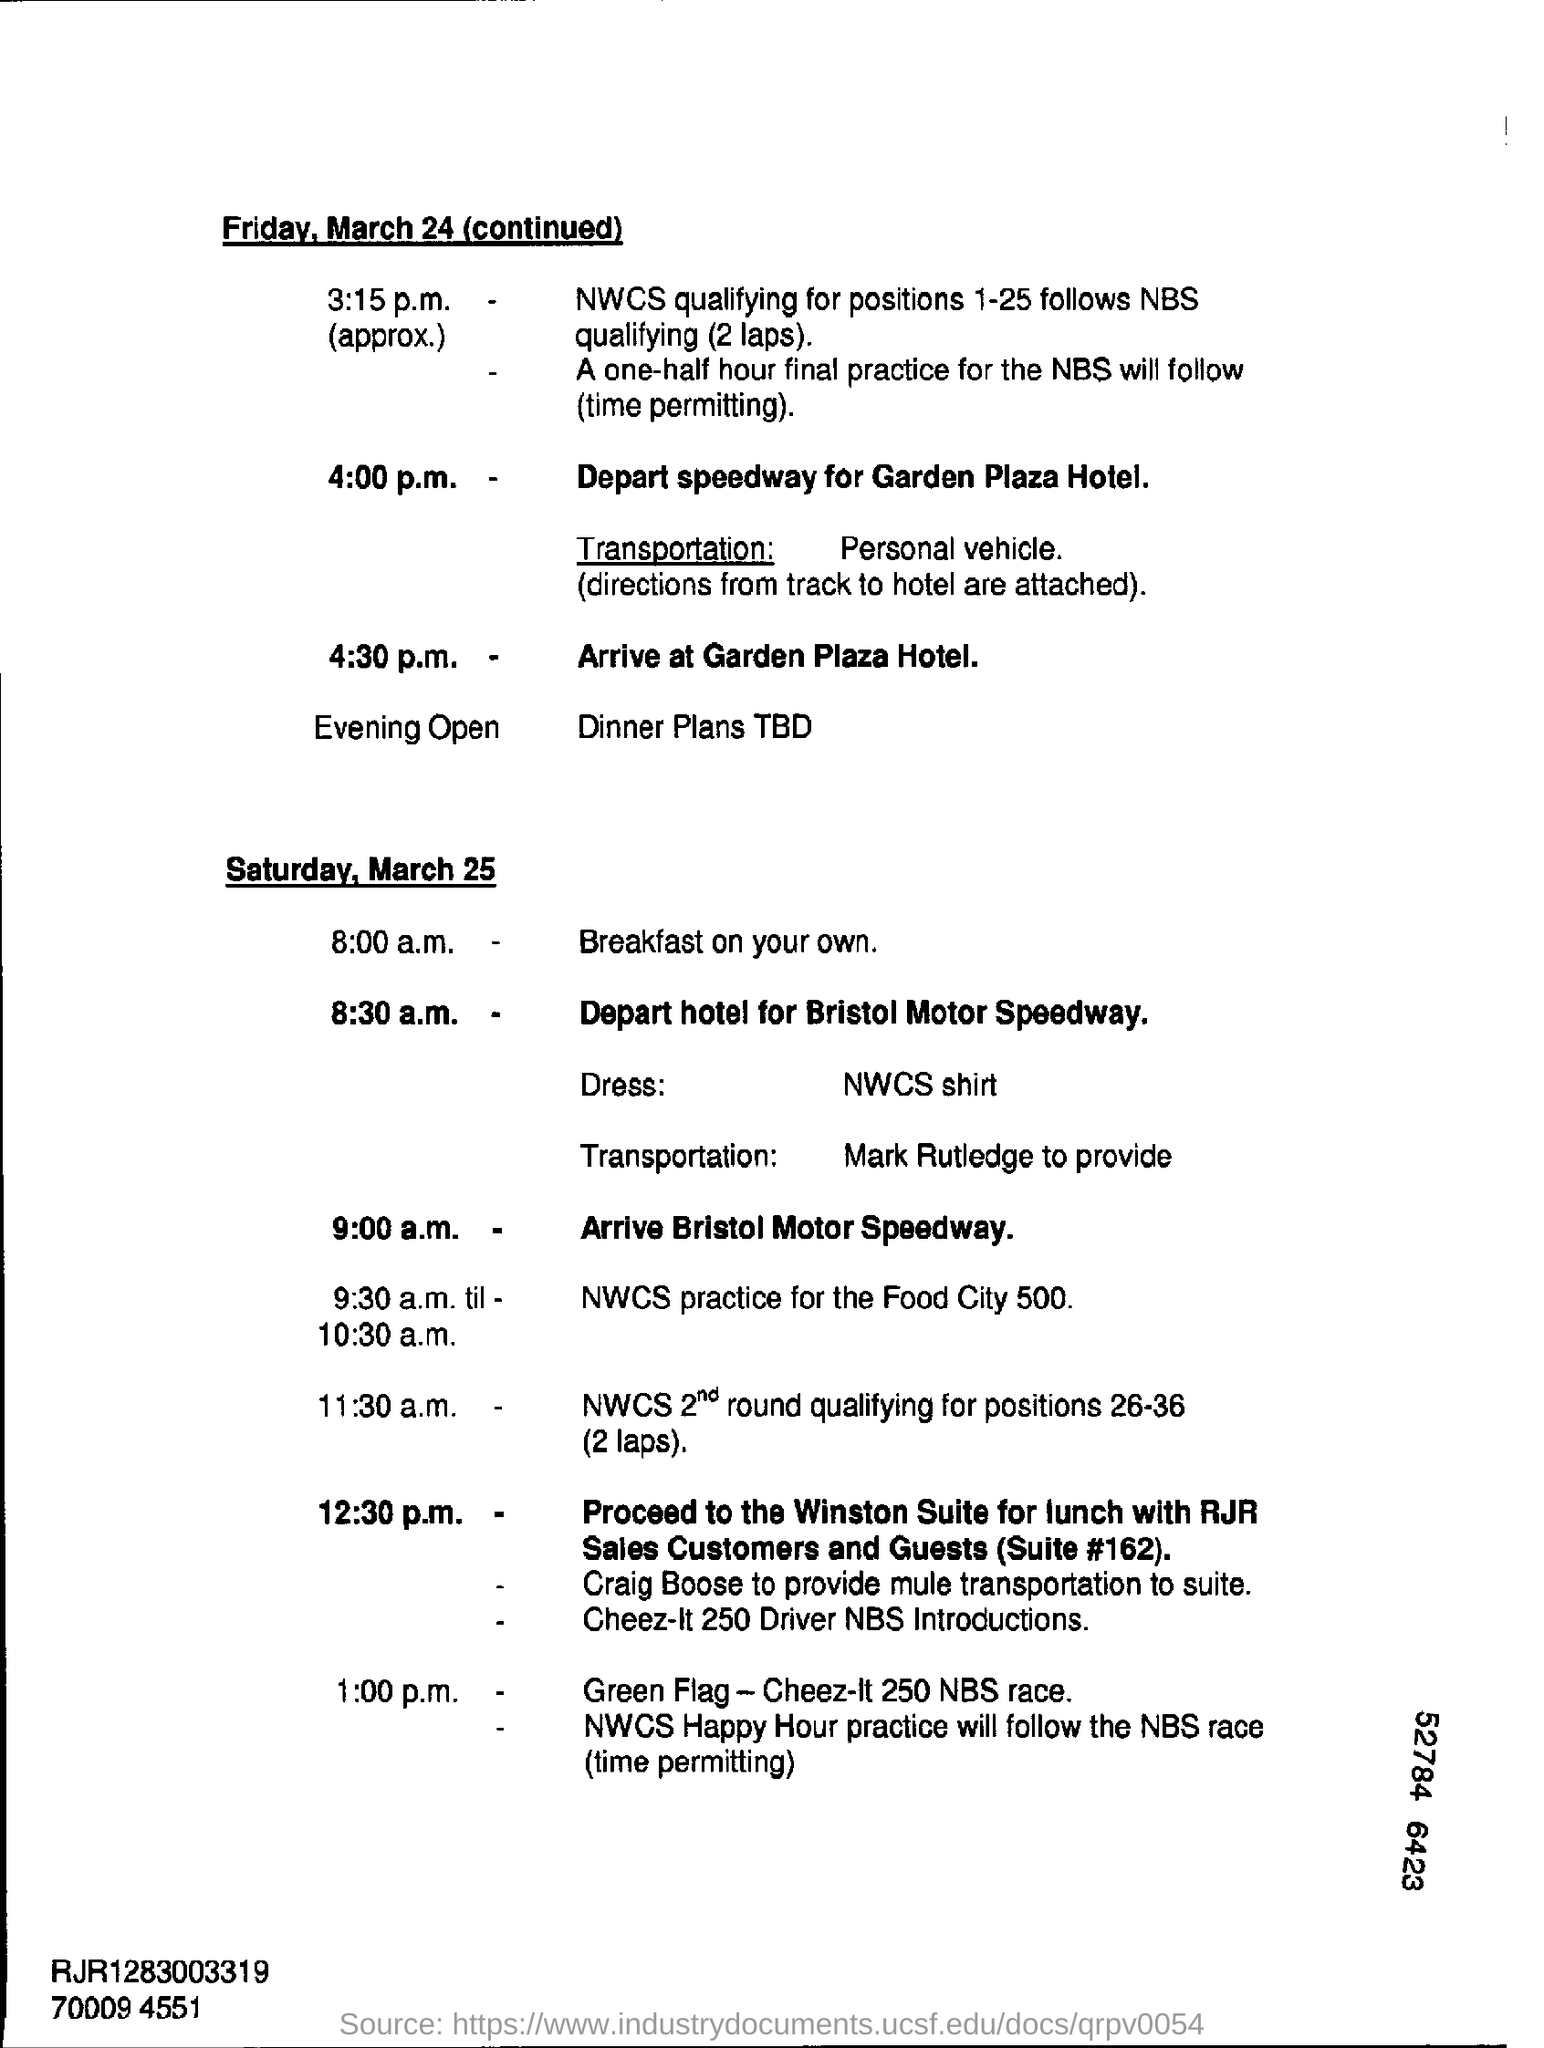Mention a couple of crucial points in this snapshot. At 4:00 p.m. on Friday, March 24, there will be an event that involves departing from the speedway and arriving at the Garden Plaza Hotel. 